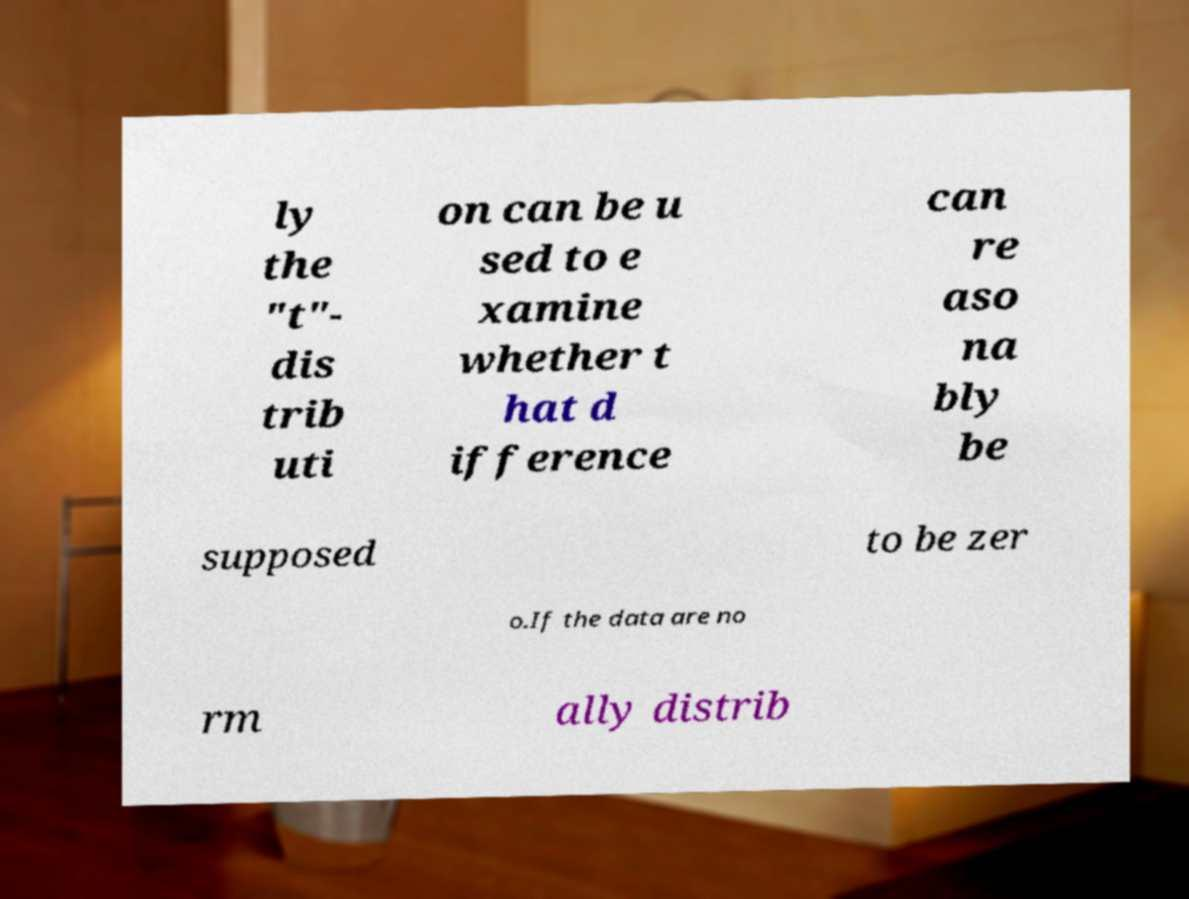Can you accurately transcribe the text from the provided image for me? ly the "t"- dis trib uti on can be u sed to e xamine whether t hat d ifference can re aso na bly be supposed to be zer o.If the data are no rm ally distrib 